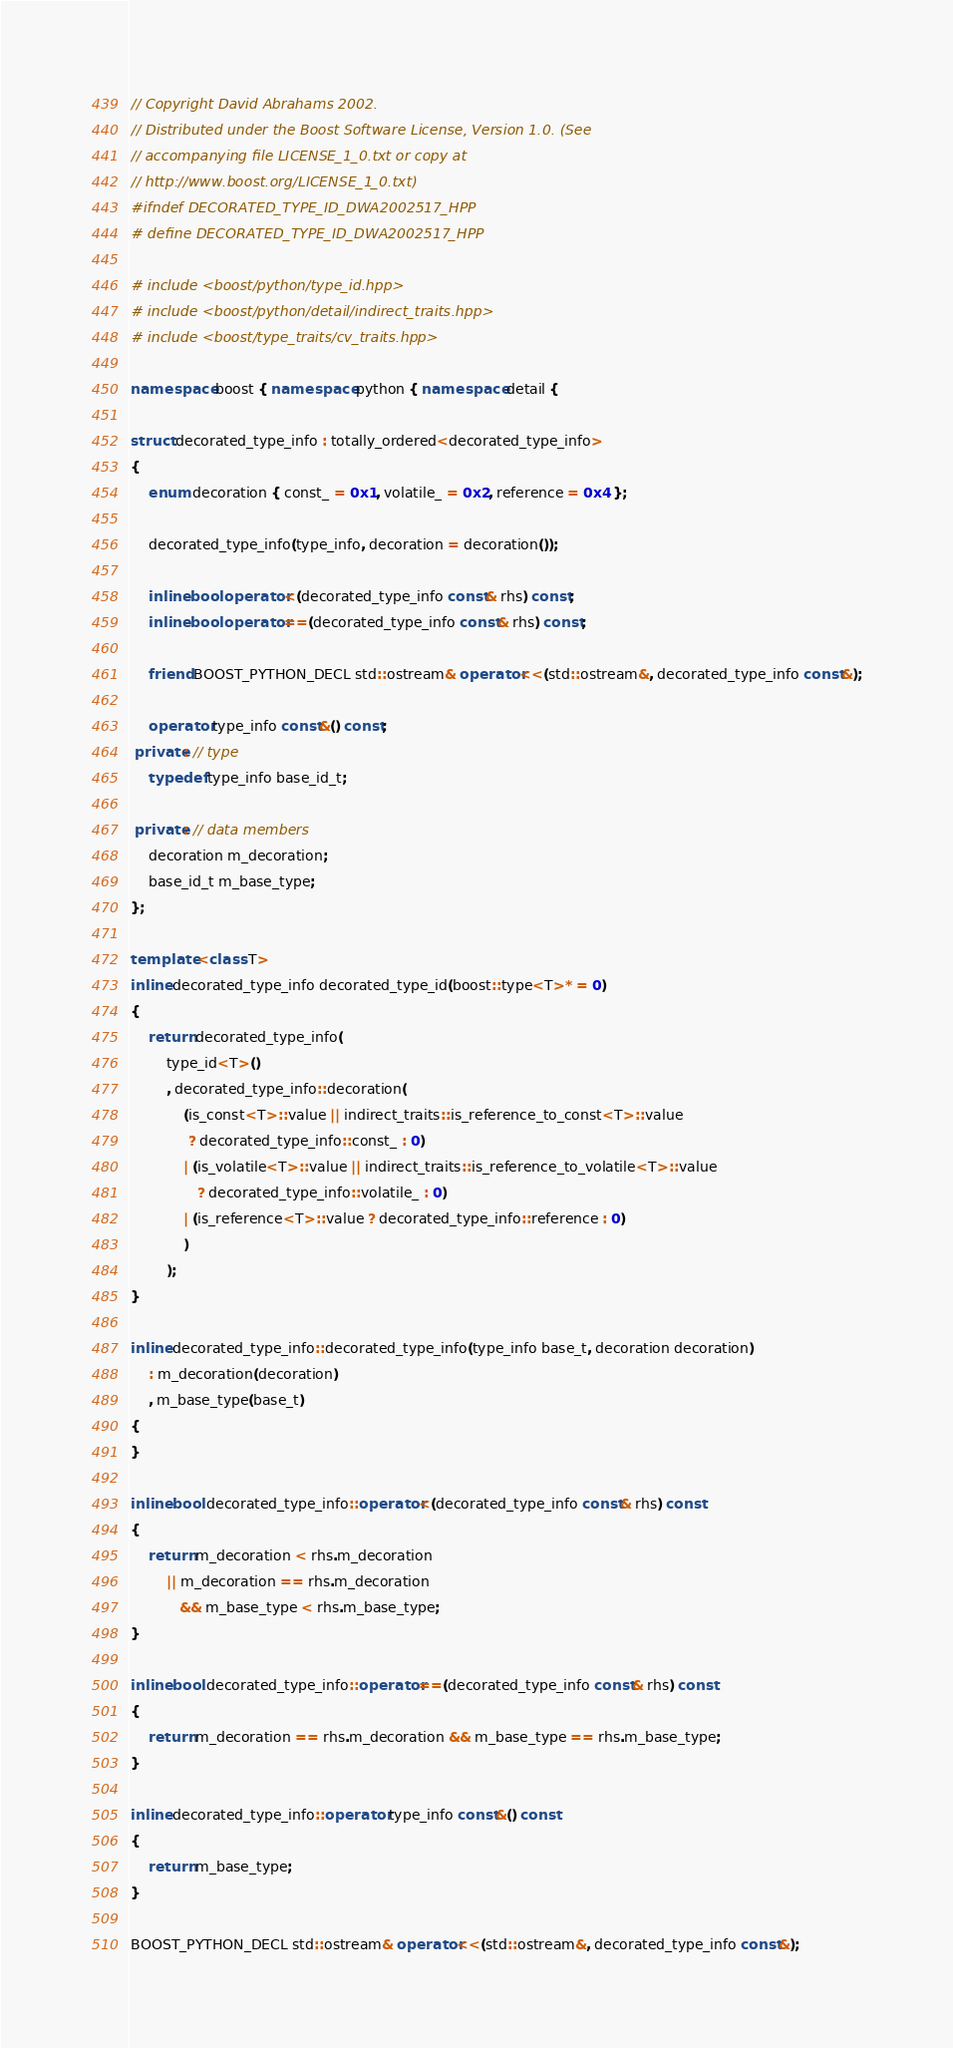Convert code to text. <code><loc_0><loc_0><loc_500><loc_500><_C++_>// Copyright David Abrahams 2002.
// Distributed under the Boost Software License, Version 1.0. (See
// accompanying file LICENSE_1_0.txt or copy at
// http://www.boost.org/LICENSE_1_0.txt)
#ifndef DECORATED_TYPE_ID_DWA2002517_HPP
# define DECORATED_TYPE_ID_DWA2002517_HPP

# include <boost/python/type_id.hpp>
# include <boost/python/detail/indirect_traits.hpp>
# include <boost/type_traits/cv_traits.hpp>

namespace boost { namespace python { namespace detail { 

struct decorated_type_info : totally_ordered<decorated_type_info>
{
    enum decoration { const_ = 0x1, volatile_ = 0x2, reference = 0x4 };
    
    decorated_type_info(type_info, decoration = decoration());

    inline bool operator<(decorated_type_info const& rhs) const;
    inline bool operator==(decorated_type_info const& rhs) const;

    friend BOOST_PYTHON_DECL std::ostream& operator<<(std::ostream&, decorated_type_info const&);

    operator type_info const&() const;
 private: // type
    typedef type_info base_id_t;
    
 private: // data members
    decoration m_decoration;
    base_id_t m_base_type;
};

template <class T>
inline decorated_type_info decorated_type_id(boost::type<T>* = 0)
{
    return decorated_type_info(
        type_id<T>()
        , decorated_type_info::decoration(
            (is_const<T>::value || indirect_traits::is_reference_to_const<T>::value
             ? decorated_type_info::const_ : 0)
            | (is_volatile<T>::value || indirect_traits::is_reference_to_volatile<T>::value
               ? decorated_type_info::volatile_ : 0)
            | (is_reference<T>::value ? decorated_type_info::reference : 0)
            )
        );
}

inline decorated_type_info::decorated_type_info(type_info base_t, decoration decoration)
    : m_decoration(decoration)
    , m_base_type(base_t)
{
}

inline bool decorated_type_info::operator<(decorated_type_info const& rhs) const
{
    return m_decoration < rhs.m_decoration
        || m_decoration == rhs.m_decoration
           && m_base_type < rhs.m_base_type;
}

inline bool decorated_type_info::operator==(decorated_type_info const& rhs) const
{
    return m_decoration == rhs.m_decoration && m_base_type == rhs.m_base_type;
}

inline decorated_type_info::operator type_info const&() const
{
    return m_base_type;
}

BOOST_PYTHON_DECL std::ostream& operator<<(std::ostream&, decorated_type_info const&);
</code> 